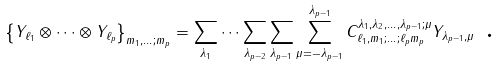Convert formula to latex. <formula><loc_0><loc_0><loc_500><loc_500>\left \{ Y _ { \ell _ { 1 } } \otimes \dots \otimes Y _ { \ell _ { p } } \right \} _ { m _ { 1 } , \dots ; m _ { p } } = \sum _ { \lambda _ { 1 } } \dots \sum _ { \lambda _ { p - 2 } } \sum _ { \lambda _ { p - 1 } } \sum _ { \mu = - \lambda _ { p - 1 } } ^ { \lambda _ { p - 1 } } C _ { \ell _ { 1 } , m _ { 1 } ; \dots ; \ell _ { p } m _ { p } } ^ { \lambda _ { 1 } , \lambda _ { 2 } , \dots , \lambda _ { p - 1 } ; \mu } Y _ { \lambda _ { p - 1 } , \mu } \text { .}</formula> 